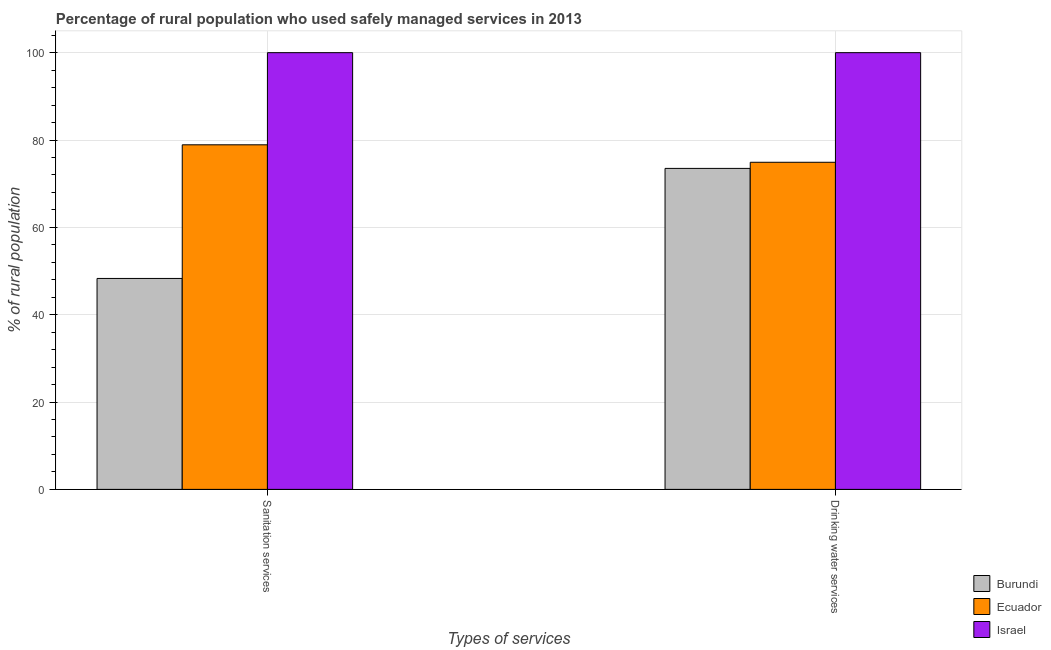What is the label of the 1st group of bars from the left?
Offer a terse response. Sanitation services. What is the percentage of rural population who used sanitation services in Israel?
Provide a succinct answer. 100. Across all countries, what is the minimum percentage of rural population who used drinking water services?
Offer a terse response. 73.5. In which country was the percentage of rural population who used drinking water services minimum?
Give a very brief answer. Burundi. What is the total percentage of rural population who used drinking water services in the graph?
Provide a short and direct response. 248.4. What is the difference between the percentage of rural population who used sanitation services in Ecuador and that in Israel?
Your answer should be very brief. -21.1. What is the difference between the percentage of rural population who used sanitation services in Ecuador and the percentage of rural population who used drinking water services in Burundi?
Give a very brief answer. 5.4. What is the average percentage of rural population who used drinking water services per country?
Provide a short and direct response. 82.8. What is the difference between the percentage of rural population who used drinking water services and percentage of rural population who used sanitation services in Burundi?
Keep it short and to the point. 25.2. What is the ratio of the percentage of rural population who used drinking water services in Israel to that in Ecuador?
Provide a short and direct response. 1.34. What does the 3rd bar from the left in Drinking water services represents?
Make the answer very short. Israel. What does the 2nd bar from the right in Drinking water services represents?
Ensure brevity in your answer.  Ecuador. How many bars are there?
Give a very brief answer. 6. How many countries are there in the graph?
Keep it short and to the point. 3. Does the graph contain any zero values?
Keep it short and to the point. No. How many legend labels are there?
Your answer should be compact. 3. How are the legend labels stacked?
Keep it short and to the point. Vertical. What is the title of the graph?
Offer a terse response. Percentage of rural population who used safely managed services in 2013. What is the label or title of the X-axis?
Make the answer very short. Types of services. What is the label or title of the Y-axis?
Ensure brevity in your answer.  % of rural population. What is the % of rural population in Burundi in Sanitation services?
Your answer should be very brief. 48.3. What is the % of rural population in Ecuador in Sanitation services?
Make the answer very short. 78.9. What is the % of rural population of Burundi in Drinking water services?
Your answer should be compact. 73.5. What is the % of rural population in Ecuador in Drinking water services?
Provide a short and direct response. 74.9. What is the % of rural population of Israel in Drinking water services?
Your answer should be very brief. 100. Across all Types of services, what is the maximum % of rural population of Burundi?
Offer a very short reply. 73.5. Across all Types of services, what is the maximum % of rural population of Ecuador?
Offer a very short reply. 78.9. Across all Types of services, what is the maximum % of rural population in Israel?
Offer a terse response. 100. Across all Types of services, what is the minimum % of rural population in Burundi?
Provide a succinct answer. 48.3. Across all Types of services, what is the minimum % of rural population in Ecuador?
Give a very brief answer. 74.9. Across all Types of services, what is the minimum % of rural population in Israel?
Ensure brevity in your answer.  100. What is the total % of rural population in Burundi in the graph?
Provide a succinct answer. 121.8. What is the total % of rural population in Ecuador in the graph?
Offer a terse response. 153.8. What is the total % of rural population in Israel in the graph?
Offer a terse response. 200. What is the difference between the % of rural population in Burundi in Sanitation services and that in Drinking water services?
Offer a terse response. -25.2. What is the difference between the % of rural population in Ecuador in Sanitation services and that in Drinking water services?
Provide a succinct answer. 4. What is the difference between the % of rural population in Burundi in Sanitation services and the % of rural population in Ecuador in Drinking water services?
Offer a very short reply. -26.6. What is the difference between the % of rural population of Burundi in Sanitation services and the % of rural population of Israel in Drinking water services?
Make the answer very short. -51.7. What is the difference between the % of rural population of Ecuador in Sanitation services and the % of rural population of Israel in Drinking water services?
Ensure brevity in your answer.  -21.1. What is the average % of rural population of Burundi per Types of services?
Your answer should be very brief. 60.9. What is the average % of rural population in Ecuador per Types of services?
Your response must be concise. 76.9. What is the average % of rural population in Israel per Types of services?
Offer a terse response. 100. What is the difference between the % of rural population in Burundi and % of rural population in Ecuador in Sanitation services?
Make the answer very short. -30.6. What is the difference between the % of rural population in Burundi and % of rural population in Israel in Sanitation services?
Keep it short and to the point. -51.7. What is the difference between the % of rural population in Ecuador and % of rural population in Israel in Sanitation services?
Your answer should be compact. -21.1. What is the difference between the % of rural population in Burundi and % of rural population in Ecuador in Drinking water services?
Provide a short and direct response. -1.4. What is the difference between the % of rural population of Burundi and % of rural population of Israel in Drinking water services?
Your response must be concise. -26.5. What is the difference between the % of rural population of Ecuador and % of rural population of Israel in Drinking water services?
Offer a terse response. -25.1. What is the ratio of the % of rural population of Burundi in Sanitation services to that in Drinking water services?
Offer a very short reply. 0.66. What is the ratio of the % of rural population of Ecuador in Sanitation services to that in Drinking water services?
Provide a succinct answer. 1.05. What is the difference between the highest and the second highest % of rural population in Burundi?
Offer a terse response. 25.2. What is the difference between the highest and the lowest % of rural population of Burundi?
Ensure brevity in your answer.  25.2. 